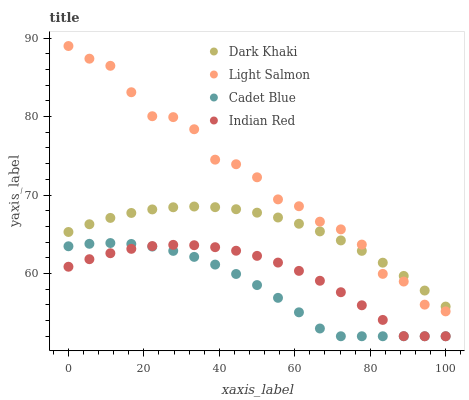Does Cadet Blue have the minimum area under the curve?
Answer yes or no. Yes. Does Light Salmon have the maximum area under the curve?
Answer yes or no. Yes. Does Light Salmon have the minimum area under the curve?
Answer yes or no. No. Does Cadet Blue have the maximum area under the curve?
Answer yes or no. No. Is Dark Khaki the smoothest?
Answer yes or no. Yes. Is Light Salmon the roughest?
Answer yes or no. Yes. Is Cadet Blue the smoothest?
Answer yes or no. No. Is Cadet Blue the roughest?
Answer yes or no. No. Does Cadet Blue have the lowest value?
Answer yes or no. Yes. Does Light Salmon have the lowest value?
Answer yes or no. No. Does Light Salmon have the highest value?
Answer yes or no. Yes. Does Cadet Blue have the highest value?
Answer yes or no. No. Is Cadet Blue less than Light Salmon?
Answer yes or no. Yes. Is Dark Khaki greater than Cadet Blue?
Answer yes or no. Yes. Does Dark Khaki intersect Light Salmon?
Answer yes or no. Yes. Is Dark Khaki less than Light Salmon?
Answer yes or no. No. Is Dark Khaki greater than Light Salmon?
Answer yes or no. No. Does Cadet Blue intersect Light Salmon?
Answer yes or no. No. 